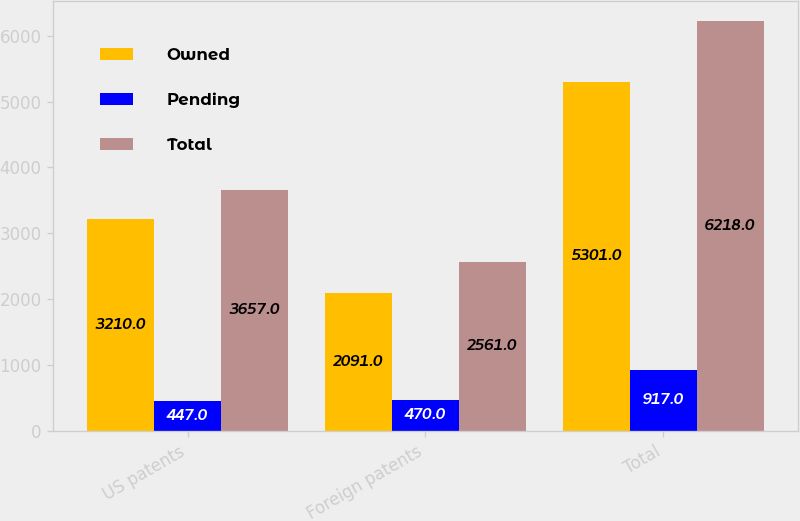<chart> <loc_0><loc_0><loc_500><loc_500><stacked_bar_chart><ecel><fcel>US patents<fcel>Foreign patents<fcel>Total<nl><fcel>Owned<fcel>3210<fcel>2091<fcel>5301<nl><fcel>Pending<fcel>447<fcel>470<fcel>917<nl><fcel>Total<fcel>3657<fcel>2561<fcel>6218<nl></chart> 